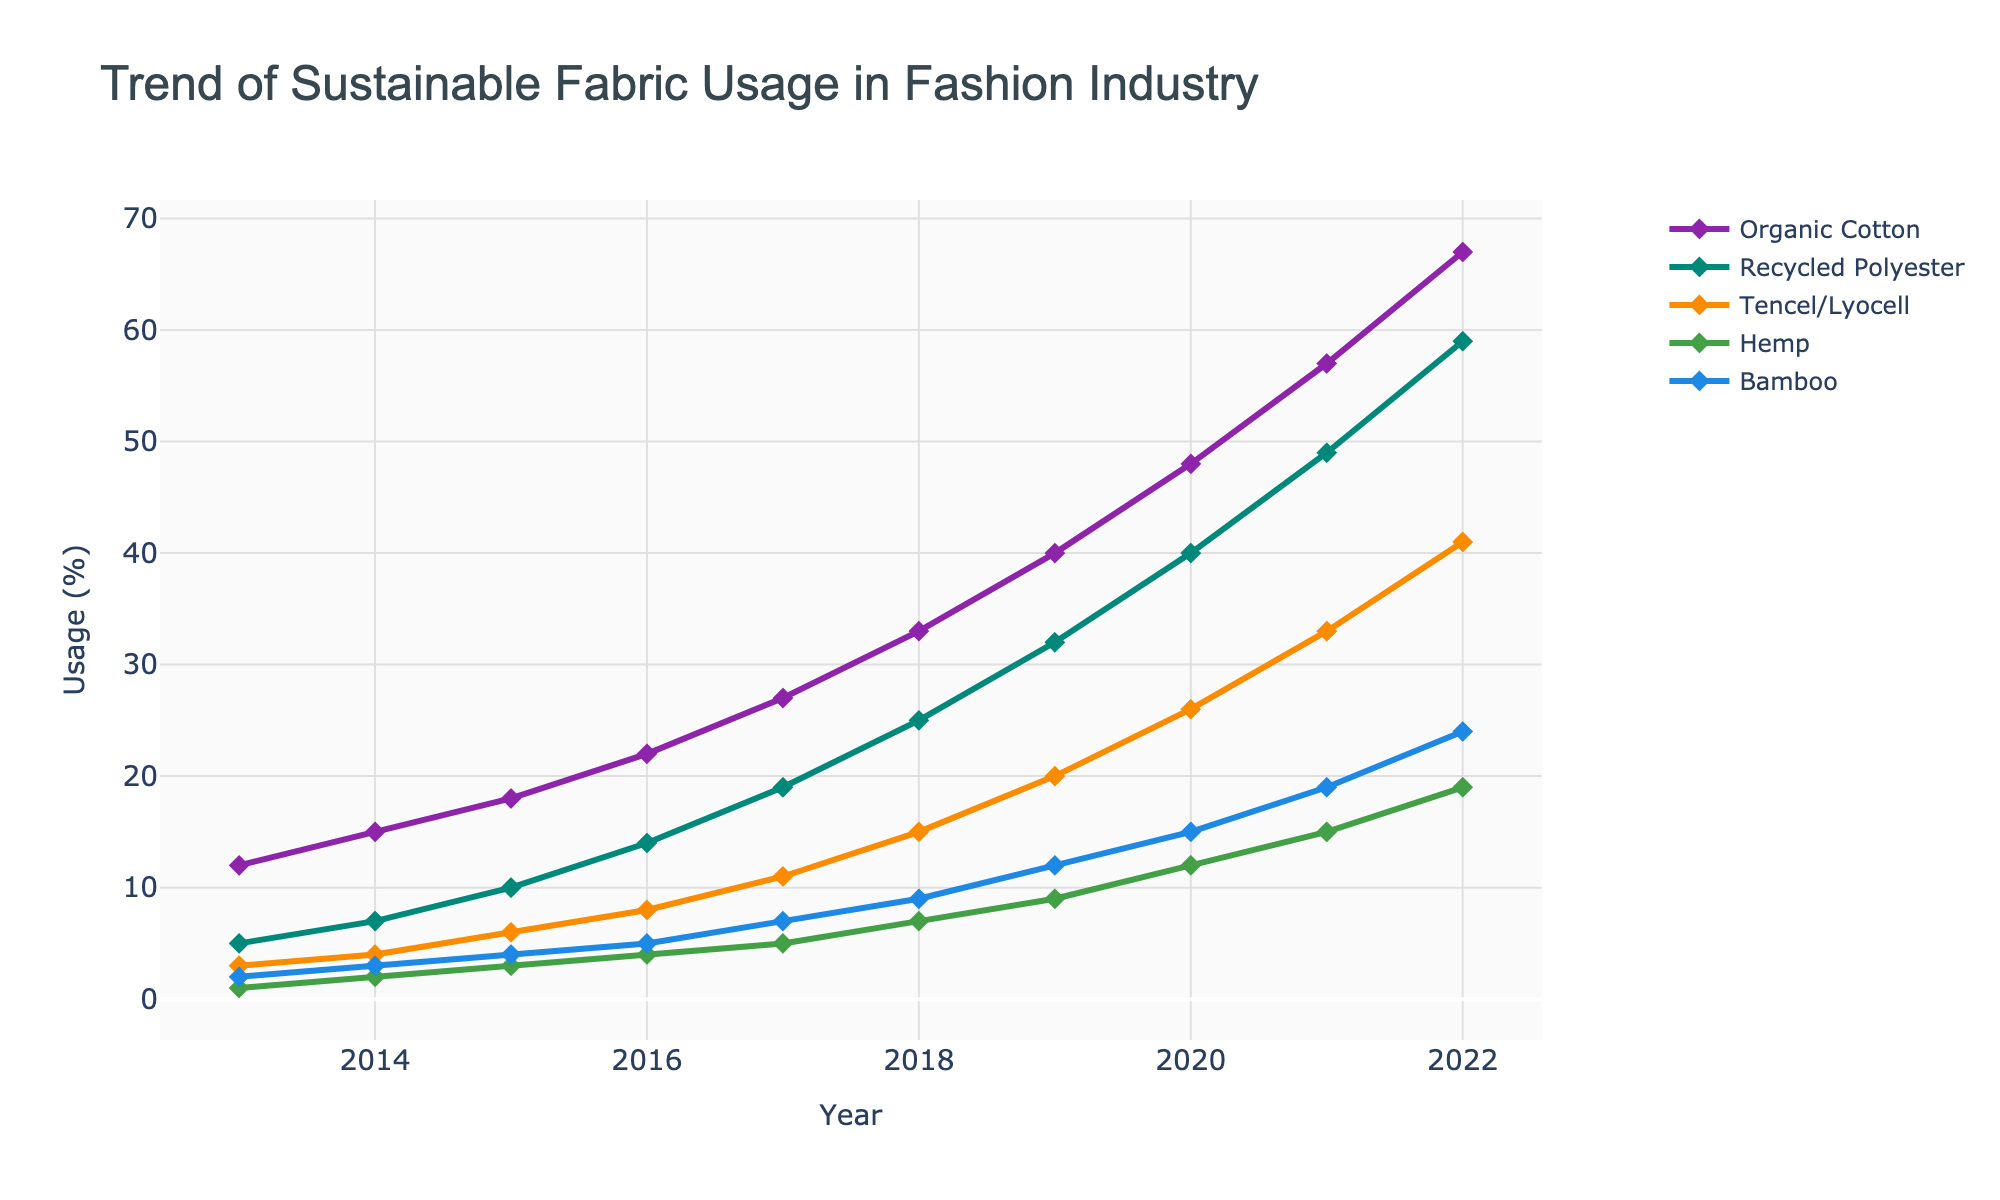What was the usage of recycled polyester in 2017? To find the usage percentage of recycled polyester in 2017, look for the data point on the line labeled 'Recycled Polyester' directly above the year 2017 on the x-axis.
Answer: 19% Which sustainable fabric showed the highest increase in usage from 2013 to 2022? To determine the fabric with the highest increase, subtract the 2013 value from the 2022 value for each material and compare the differences. Organic Cotton increased from 12 to 67 (55 points). Recycled Polyester increased from 5 to 59 (54 points). Tencel/Lyocell increased from 3 to 41 (38 points). Hemp increased from 1 to 19 (18 points). Bamboo increased from 2 to 24 (22 points).
Answer: Organic Cotton Between 2015 and 2017, which fabric type saw the largest percentage increase in usage? Calculate the percentage increase from 2015 to 2017 for each fabric by using the formula: ((value in 2017 - value in 2015) / value in 2015) * 100.
Answer: Organic Cotton In which year did bamboo surpass hemp in usage percentage? Identify the year where the line for Bamboo crosses above the line for Hemp.
Answer: 2018 Compare the usage of Tencel/Lyocell and Bamboo in 2019. Which was higher, and by how much? Locate the values for Tencel/Lyocell and Bamboo in 2019 and subtract the value of Bamboo from Tencel/Lyocell. Tencel/Lyocell was 20% and Bamboo was 12%.
Answer: Tencel/Lyocell, 8% On average, how much did the usage of organic cotton increase per year over the period 2013 to 2022? Compute the total increase for organic cotton from 2013 to 2022 and divide by the number of years (2022-2013 = 9 years). The increase is (67-12) = 55 points. Average increase per year is 55/9.
Answer: 6.11% Which year showed the steepest increase in usage for recycled polyester and what was the increase from the previous year? Identify the year where the slope of the line for Recycled Polyester is steepest, which looks like the year 2014 to 2015. Calculate the difference: 10 - 7 = 3%.
Answer: 2015, 3% What is the combined usage percentage of hemp and bamboo in 2020? Add the usage values of Hemp and Bamboo for the year 2020: Hemp (12) + Bamboo (15) = 27%.
Answer: 27% In which year did all fabric types collectively reach at least double their 2013 usage? Double the 2013 values and then check each year to see when all fabric types exceed these values. Organic Cotton: 12*2=24, Recycled Polyester: 5*2=10, Tencel/Lyocell: 3*2=6, Hemp: 1*2=2, Bamboo: 2*2=4. All these values are surpassed by 2016 for Tencel/Lyocell and earlier years likewise.
Answer: 2016 Which fabric consistently increased in usage every year throughout the decade? Check each fabric line to ensure no year shows a decrease from the previous year.
Answer: All fabric types 